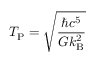Convert formula to latex. <formula><loc_0><loc_0><loc_500><loc_500>T _ { P } = { \sqrt { \frac { \hbar { c } ^ { 5 } } { G k _ { B } ^ { 2 } } } }</formula> 